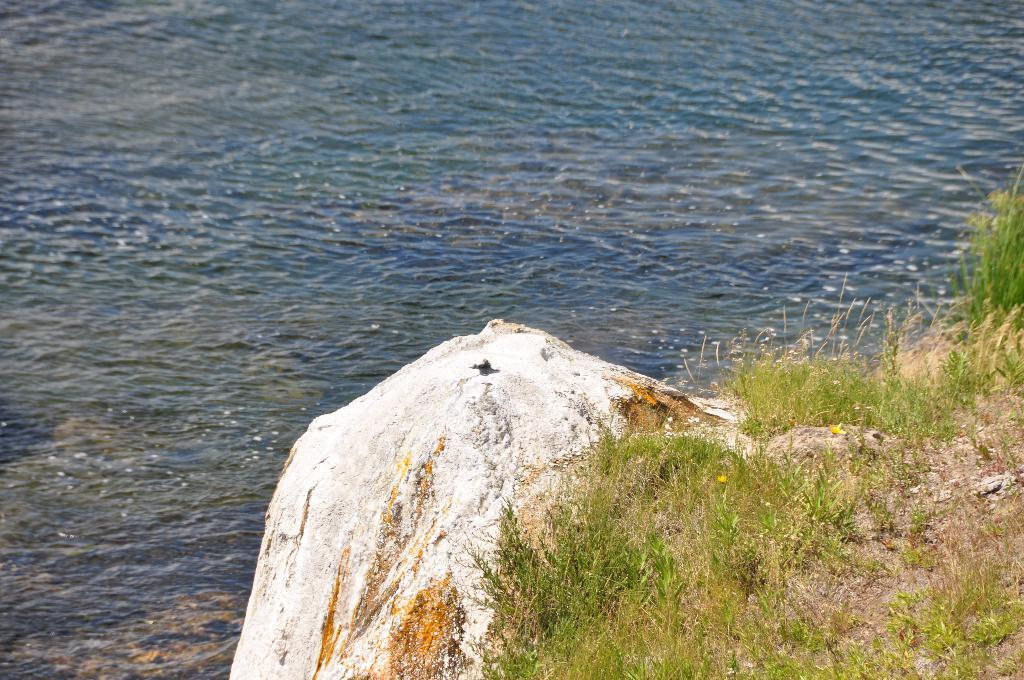What is one of the natural elements present in the image? There is water in the image. What type of land feature can be seen in the image? There is a rock in the image. What type of vegetation is present in the image? There is grass in the image. What type of hospital can be seen in the image? There is no hospital present in the image; it features natural elements such as water, a rock, and grass. How many dolls are visible in the image? There are no dolls present in the image. 